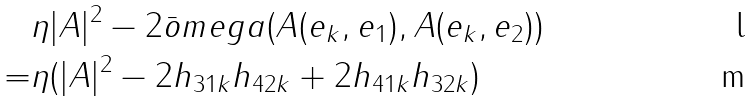Convert formula to latex. <formula><loc_0><loc_0><loc_500><loc_500>& \eta | A | ^ { 2 } - 2 \bar { o } m e g a ( A ( e _ { k } , e _ { 1 } ) , A ( e _ { k } , e _ { 2 } ) ) \\ = & \eta ( | A | ^ { 2 } - 2 h _ { 3 1 k } h _ { 4 2 k } + 2 h _ { 4 1 k } h _ { 3 2 k } )</formula> 